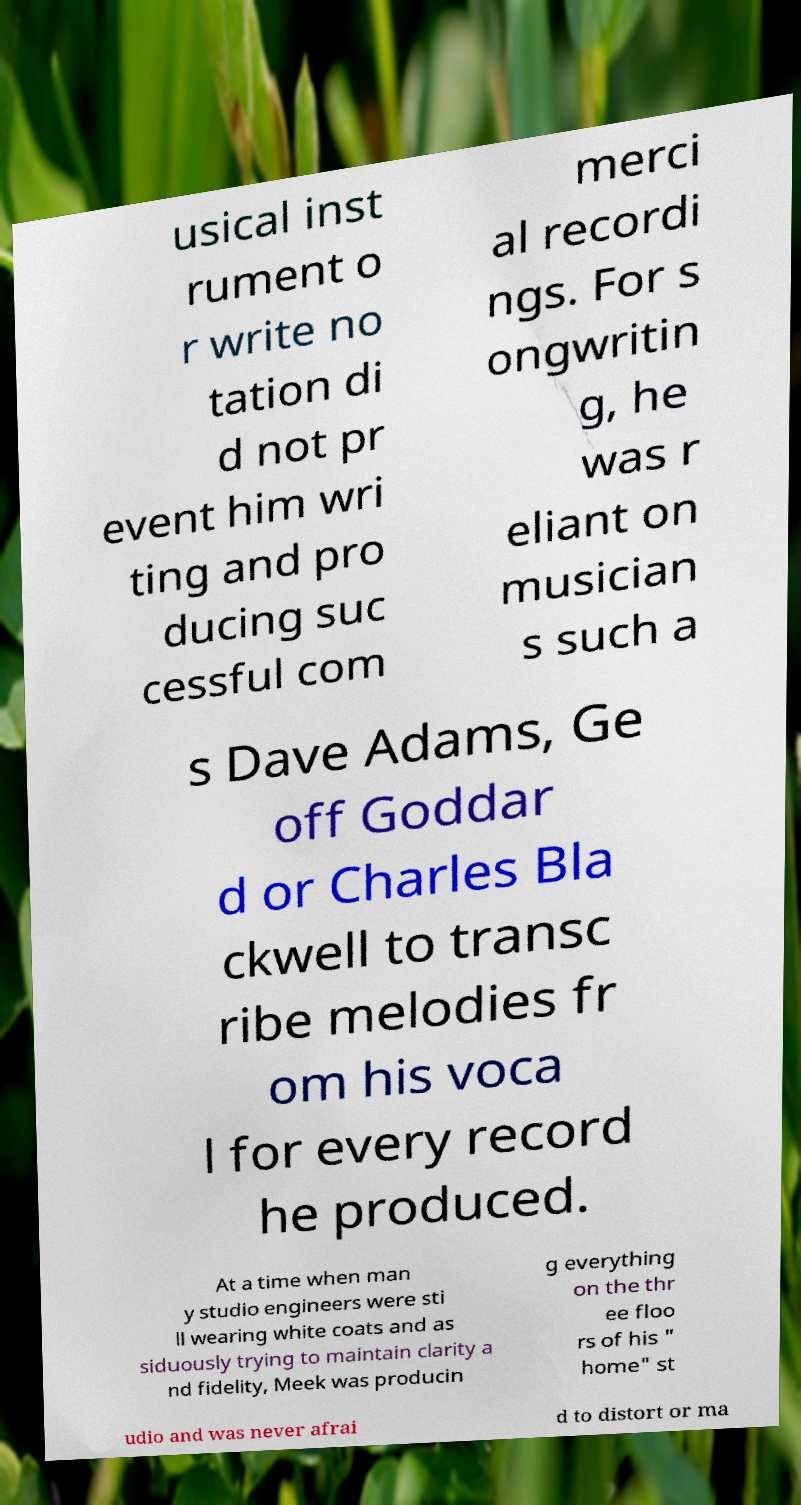For documentation purposes, I need the text within this image transcribed. Could you provide that? usical inst rument o r write no tation di d not pr event him wri ting and pro ducing suc cessful com merci al recordi ngs. For s ongwritin g, he was r eliant on musician s such a s Dave Adams, Ge off Goddar d or Charles Bla ckwell to transc ribe melodies fr om his voca l for every record he produced. At a time when man y studio engineers were sti ll wearing white coats and as siduously trying to maintain clarity a nd fidelity, Meek was producin g everything on the thr ee floo rs of his " home" st udio and was never afrai d to distort or ma 